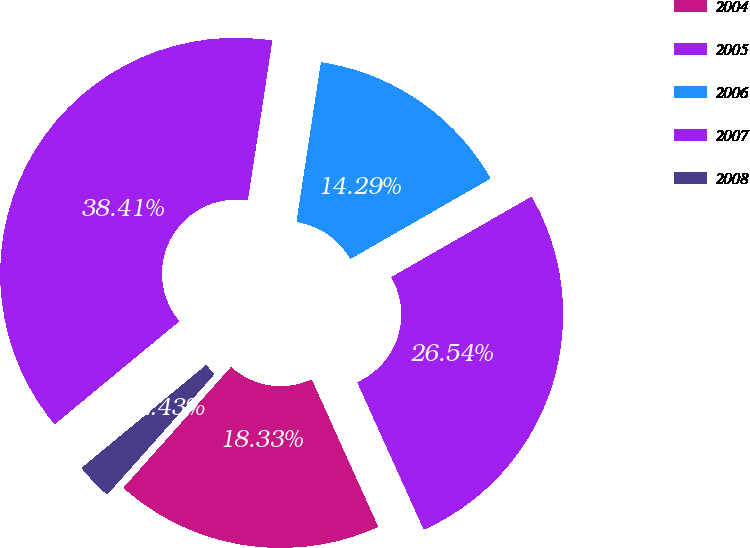Convert chart. <chart><loc_0><loc_0><loc_500><loc_500><pie_chart><fcel>2004<fcel>2005<fcel>2006<fcel>2007<fcel>2008<nl><fcel>18.33%<fcel>26.54%<fcel>14.29%<fcel>38.41%<fcel>2.43%<nl></chart> 